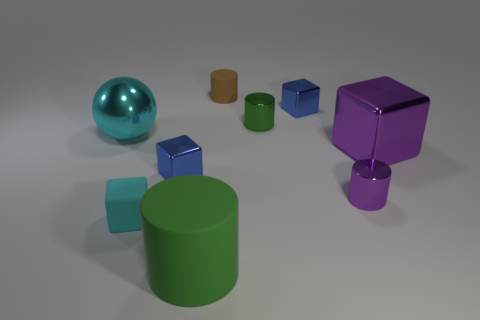What is the texture of the objects in the image like? The objects appear to have a smooth texture with a matte finish, which gives them a soft appearance in the lighting provided. Their surfaces reflect light to varying degrees, indicating different material properties. 